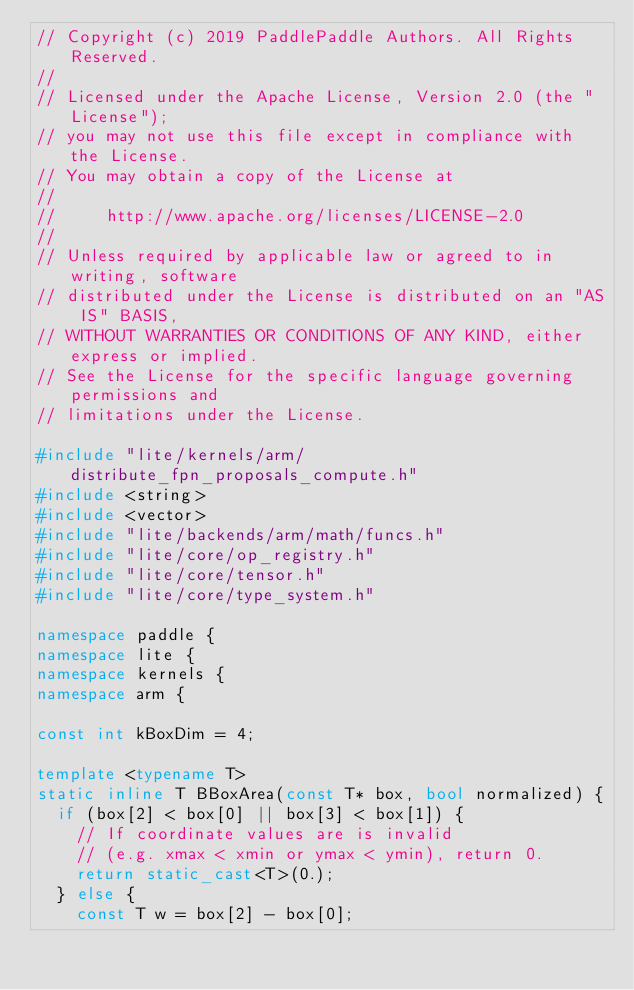Convert code to text. <code><loc_0><loc_0><loc_500><loc_500><_C++_>// Copyright (c) 2019 PaddlePaddle Authors. All Rights Reserved.
//
// Licensed under the Apache License, Version 2.0 (the "License");
// you may not use this file except in compliance with the License.
// You may obtain a copy of the License at
//
//     http://www.apache.org/licenses/LICENSE-2.0
//
// Unless required by applicable law or agreed to in writing, software
// distributed under the License is distributed on an "AS IS" BASIS,
// WITHOUT WARRANTIES OR CONDITIONS OF ANY KIND, either express or implied.
// See the License for the specific language governing permissions and
// limitations under the License.

#include "lite/kernels/arm/distribute_fpn_proposals_compute.h"
#include <string>
#include <vector>
#include "lite/backends/arm/math/funcs.h"
#include "lite/core/op_registry.h"
#include "lite/core/tensor.h"
#include "lite/core/type_system.h"

namespace paddle {
namespace lite {
namespace kernels {
namespace arm {

const int kBoxDim = 4;

template <typename T>
static inline T BBoxArea(const T* box, bool normalized) {
  if (box[2] < box[0] || box[3] < box[1]) {
    // If coordinate values are is invalid
    // (e.g. xmax < xmin or ymax < ymin), return 0.
    return static_cast<T>(0.);
  } else {
    const T w = box[2] - box[0];</code> 